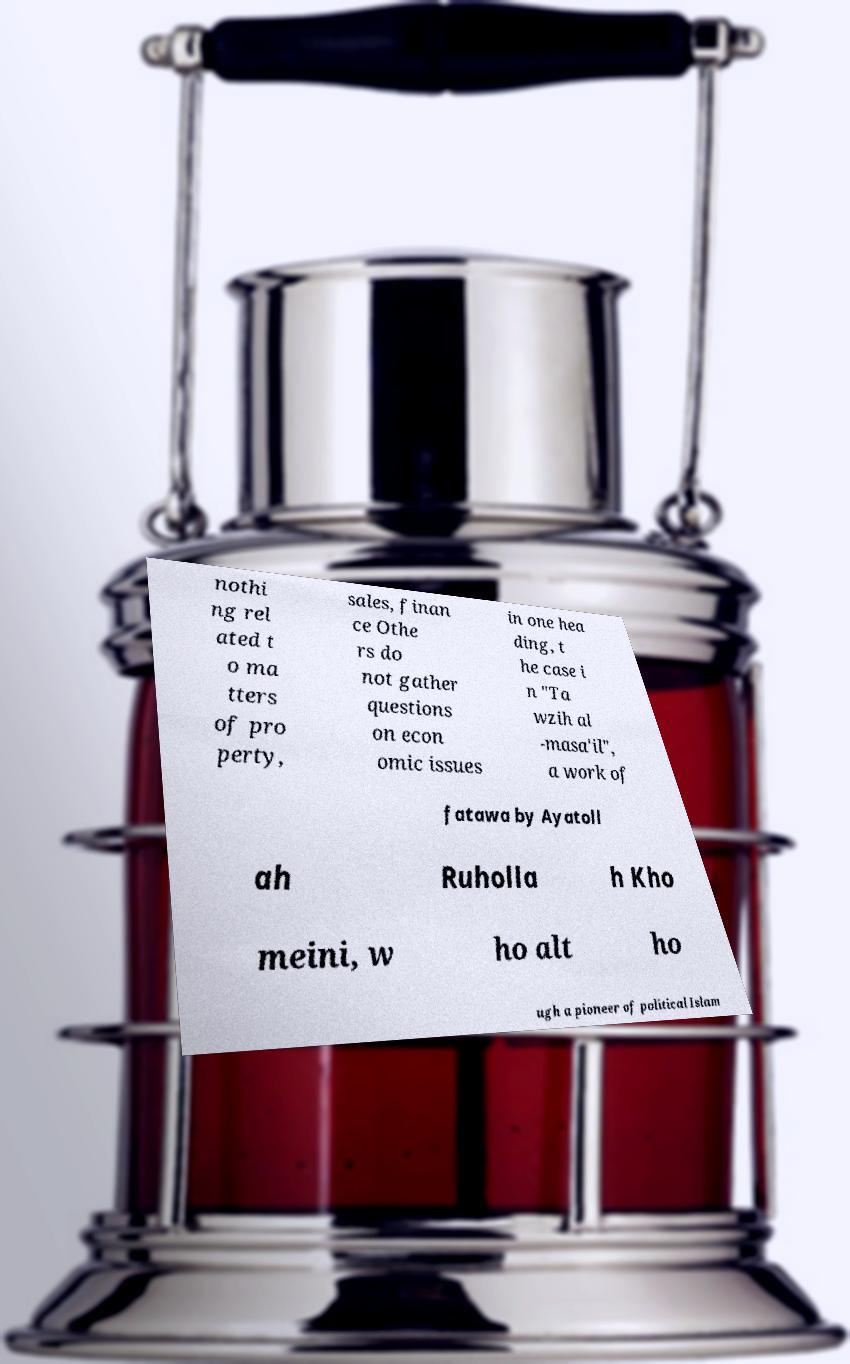Could you extract and type out the text from this image? nothi ng rel ated t o ma tters of pro perty, sales, finan ce Othe rs do not gather questions on econ omic issues in one hea ding, t he case i n "Ta wzih al -masa'il", a work of fatawa by Ayatoll ah Ruholla h Kho meini, w ho alt ho ugh a pioneer of political Islam 